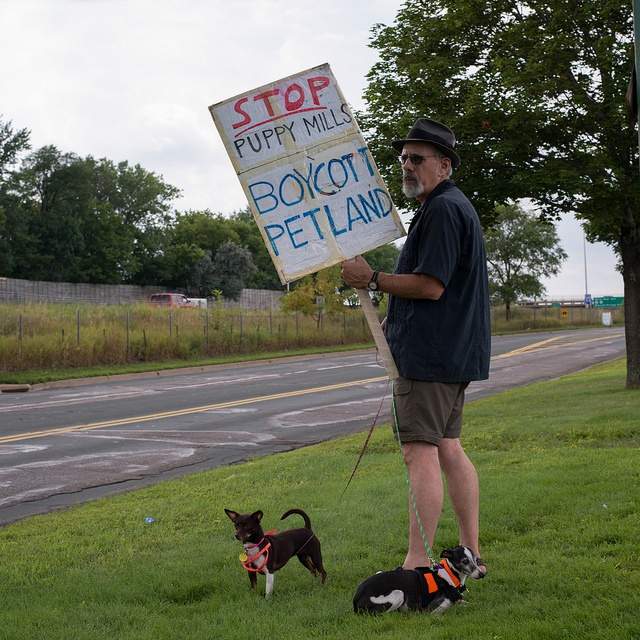Describe the objects in this image and their specific colors. I can see people in white, black, gray, and maroon tones, dog in white, black, darkgray, gray, and darkgreen tones, dog in white, black, gray, darkgreen, and maroon tones, and truck in white, gray, and black tones in this image. 